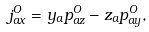Convert formula to latex. <formula><loc_0><loc_0><loc_500><loc_500>j _ { a x } ^ { O } = y _ { a } p _ { a z } ^ { O } - z _ { a } p _ { a y } ^ { O } ,</formula> 